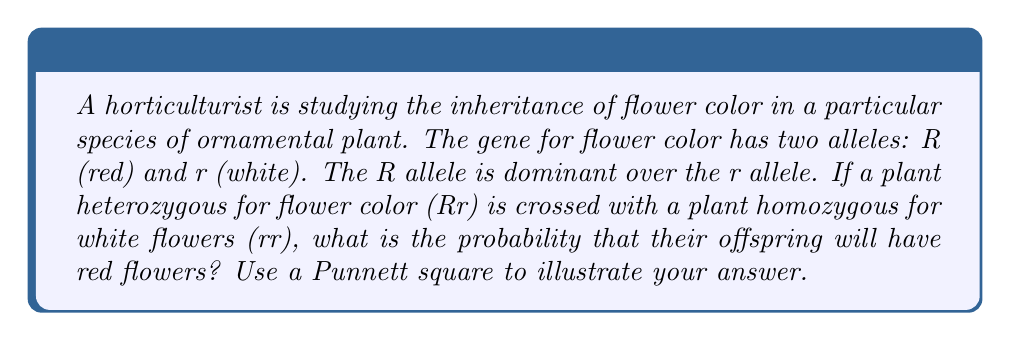Can you solve this math problem? To solve this problem, we need to follow these steps:

1. Identify the genotypes of the parent plants:
   - Parent 1 (heterozygous for red flowers): Rr
   - Parent 2 (homozygous for white flowers): rr

2. Create a Punnett square to visualize the possible genetic combinations:

   $$
   \begin{array}{c|c|c}
    & \text{R} & \text{r} \\
   \hline
   \text{r} & \text{Rr} & \text{rr} \\
   \hline
   \text{r} & \text{Rr} & \text{rr}
   \end{array}
   $$

3. Analyze the Punnett square:
   - There are four possible outcomes: Rr, Rr, rr, rr
   - Two out of four outcomes have the genotype Rr

4. Determine the phenotypes:
   - Rr genotype produces red flowers (R is dominant)
   - rr genotype produces white flowers

5. Calculate the probability:
   - Probability of red flowers = $\frac{\text{Number of Rr outcomes}}{\text{Total number of outcomes}}$
   - Probability of red flowers = $\frac{2}{4} = \frac{1}{2} = 0.5$ or 50%

The probability that the offspring will have red flowers is 0.5 or 50%.
Answer: The probability that the offspring will have red flowers is 0.5 or 50%. 